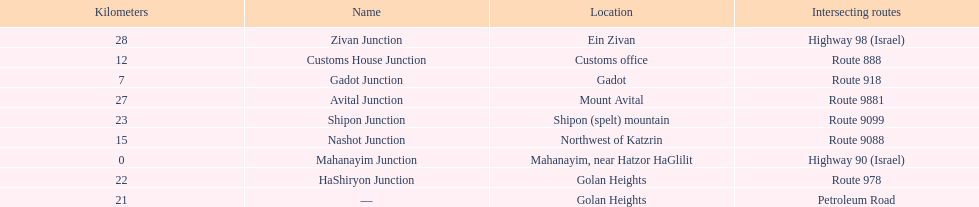Which junction on highway 91 is closer to ein zivan, gadot junction or shipon junction? Gadot Junction. 